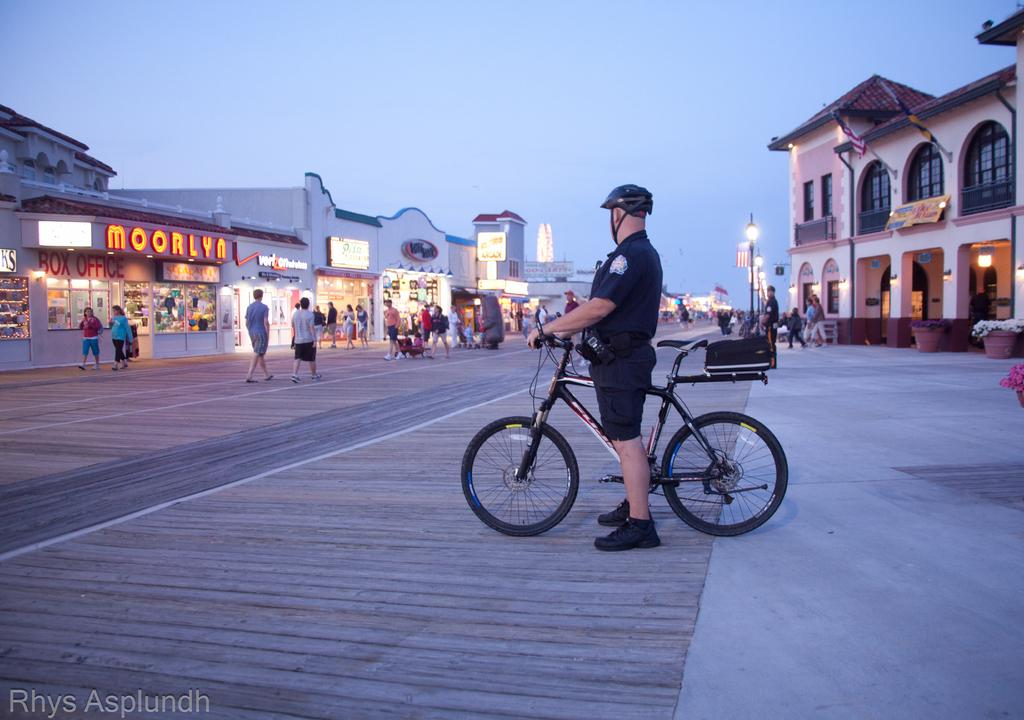What type of structures can be seen in the image? There are buildings in the image. Who or what else is present in the image? There are people in the image, including a man holding a bicycle. What can be seen illuminating the scene in the image? There are lights visible in the image. What is visible at the top of the image? The sky is visible at the top of the image. How does the fact affect the impulse of the sneeze in the image? There is no fact, impulse, or sneeze present in the image; it features buildings, people, lights, and a man holding a bicycle. 